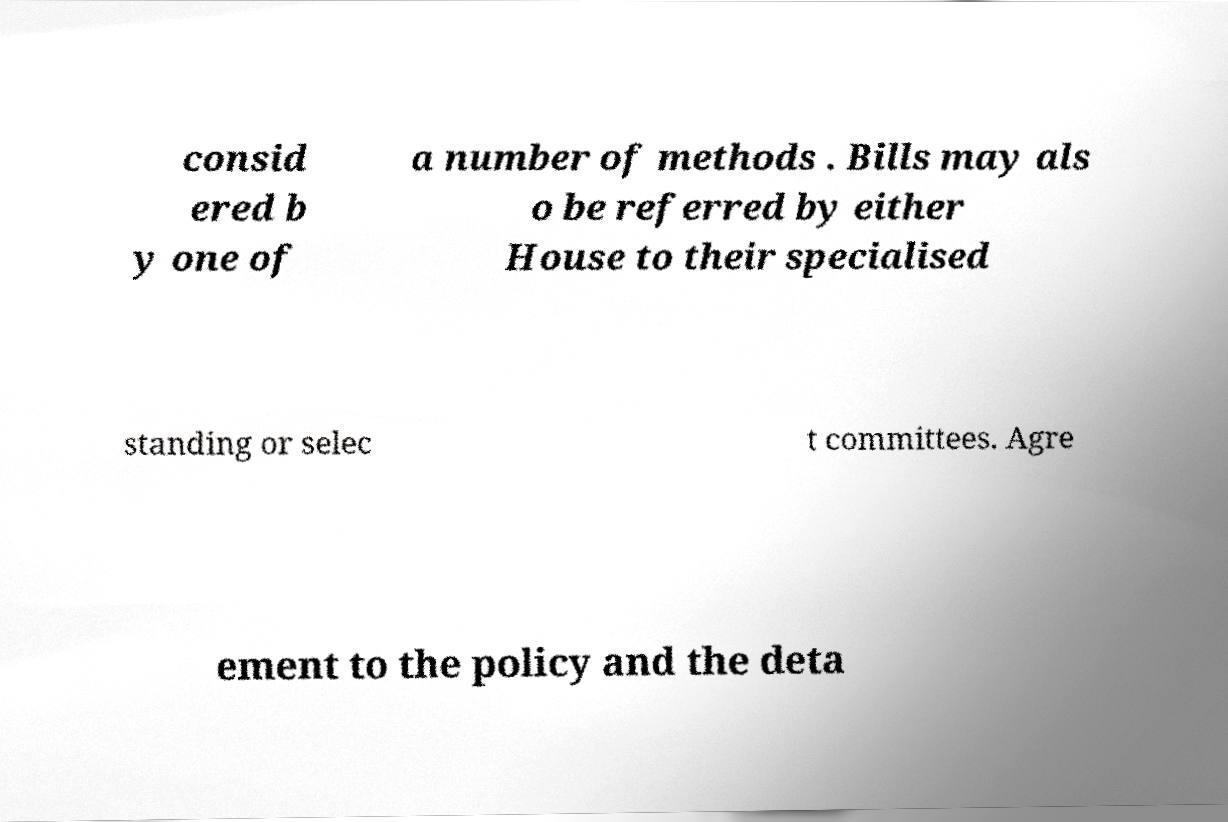Can you read and provide the text displayed in the image?This photo seems to have some interesting text. Can you extract and type it out for me? consid ered b y one of a number of methods . Bills may als o be referred by either House to their specialised standing or selec t committees. Agre ement to the policy and the deta 